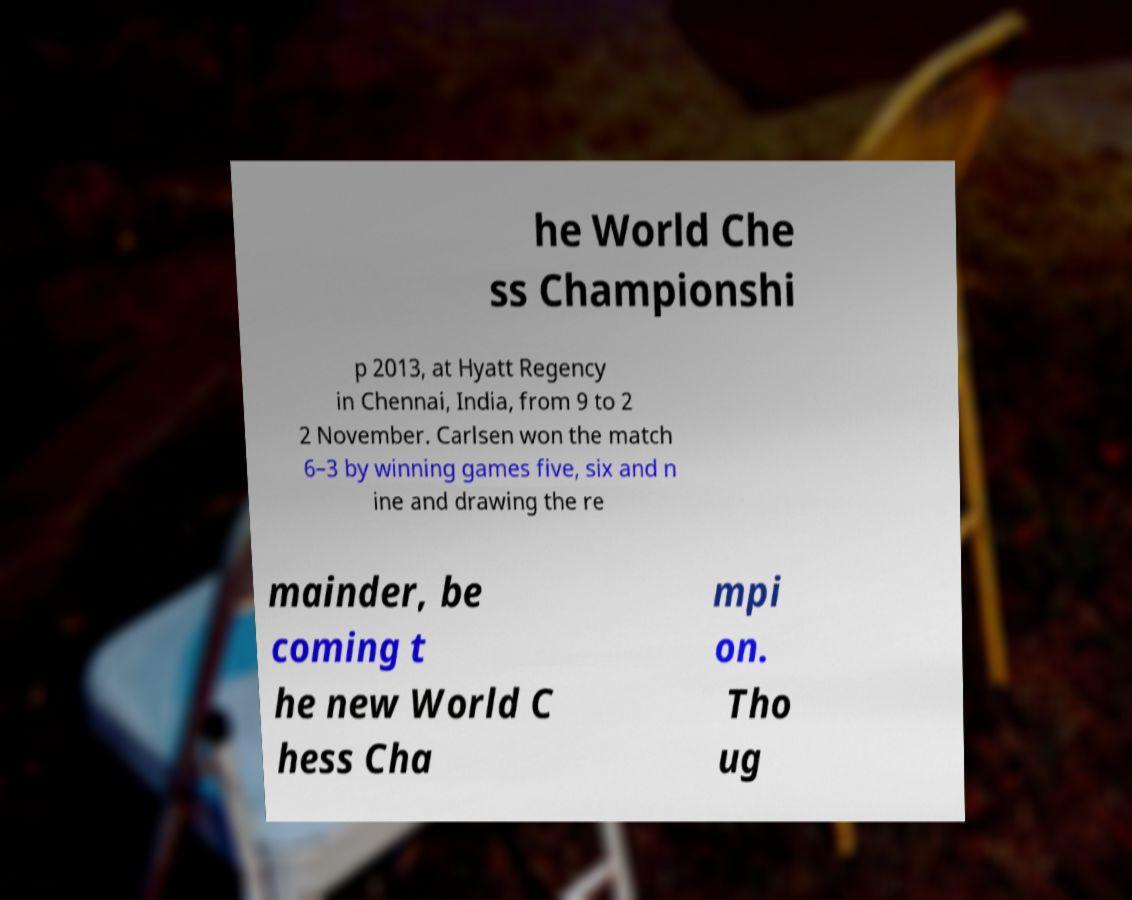What messages or text are displayed in this image? I need them in a readable, typed format. he World Che ss Championshi p 2013, at Hyatt Regency in Chennai, India, from 9 to 2 2 November. Carlsen won the match 6–3 by winning games five, six and n ine and drawing the re mainder, be coming t he new World C hess Cha mpi on. Tho ug 